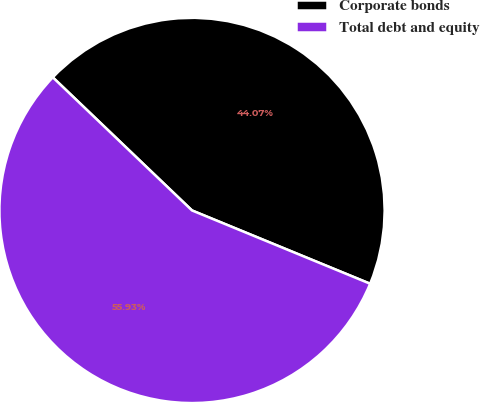Convert chart to OTSL. <chart><loc_0><loc_0><loc_500><loc_500><pie_chart><fcel>Corporate bonds<fcel>Total debt and equity<nl><fcel>44.07%<fcel>55.93%<nl></chart> 